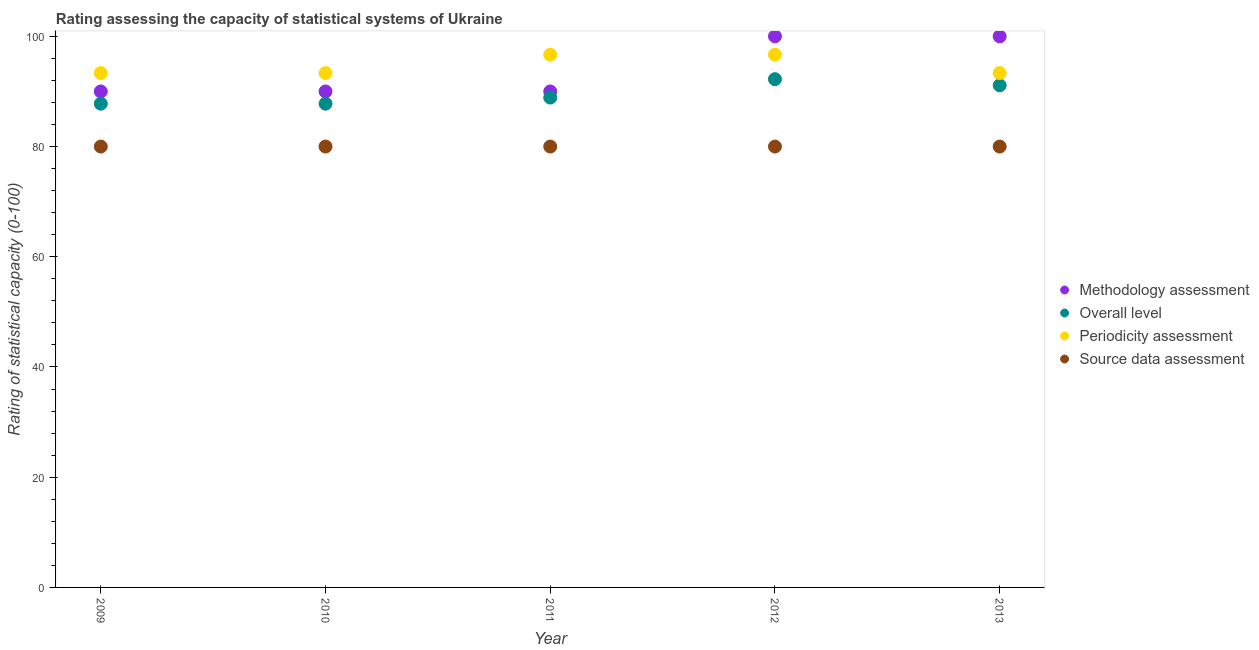How many different coloured dotlines are there?
Provide a short and direct response. 4. Is the number of dotlines equal to the number of legend labels?
Your response must be concise. Yes. What is the overall level rating in 2013?
Make the answer very short. 91.11. Across all years, what is the maximum overall level rating?
Keep it short and to the point. 92.22. Across all years, what is the minimum overall level rating?
Your answer should be compact. 87.78. In which year was the source data assessment rating minimum?
Make the answer very short. 2009. What is the total overall level rating in the graph?
Your response must be concise. 447.78. What is the difference between the source data assessment rating in 2013 and the periodicity assessment rating in 2009?
Keep it short and to the point. -13.33. What is the average periodicity assessment rating per year?
Offer a terse response. 94.67. In the year 2012, what is the difference between the methodology assessment rating and source data assessment rating?
Offer a terse response. 20. What is the ratio of the methodology assessment rating in 2009 to that in 2013?
Provide a succinct answer. 0.9. What is the difference between the highest and the second highest methodology assessment rating?
Offer a very short reply. 0. Is it the case that in every year, the sum of the methodology assessment rating and overall level rating is greater than the periodicity assessment rating?
Make the answer very short. Yes. Does the periodicity assessment rating monotonically increase over the years?
Your answer should be very brief. No. Is the overall level rating strictly greater than the source data assessment rating over the years?
Provide a succinct answer. Yes. How many dotlines are there?
Give a very brief answer. 4. How many years are there in the graph?
Keep it short and to the point. 5. What is the difference between two consecutive major ticks on the Y-axis?
Offer a very short reply. 20. Does the graph contain grids?
Give a very brief answer. No. How many legend labels are there?
Your response must be concise. 4. How are the legend labels stacked?
Provide a short and direct response. Vertical. What is the title of the graph?
Give a very brief answer. Rating assessing the capacity of statistical systems of Ukraine. What is the label or title of the X-axis?
Your response must be concise. Year. What is the label or title of the Y-axis?
Your answer should be compact. Rating of statistical capacity (0-100). What is the Rating of statistical capacity (0-100) in Overall level in 2009?
Provide a short and direct response. 87.78. What is the Rating of statistical capacity (0-100) of Periodicity assessment in 2009?
Your answer should be compact. 93.33. What is the Rating of statistical capacity (0-100) of Source data assessment in 2009?
Offer a very short reply. 80. What is the Rating of statistical capacity (0-100) of Overall level in 2010?
Your answer should be very brief. 87.78. What is the Rating of statistical capacity (0-100) of Periodicity assessment in 2010?
Make the answer very short. 93.33. What is the Rating of statistical capacity (0-100) of Overall level in 2011?
Give a very brief answer. 88.89. What is the Rating of statistical capacity (0-100) of Periodicity assessment in 2011?
Your response must be concise. 96.67. What is the Rating of statistical capacity (0-100) in Methodology assessment in 2012?
Provide a succinct answer. 100. What is the Rating of statistical capacity (0-100) in Overall level in 2012?
Ensure brevity in your answer.  92.22. What is the Rating of statistical capacity (0-100) of Periodicity assessment in 2012?
Your answer should be compact. 96.67. What is the Rating of statistical capacity (0-100) in Source data assessment in 2012?
Offer a very short reply. 80. What is the Rating of statistical capacity (0-100) of Overall level in 2013?
Provide a short and direct response. 91.11. What is the Rating of statistical capacity (0-100) in Periodicity assessment in 2013?
Give a very brief answer. 93.33. What is the Rating of statistical capacity (0-100) of Source data assessment in 2013?
Offer a very short reply. 80. Across all years, what is the maximum Rating of statistical capacity (0-100) of Methodology assessment?
Your answer should be very brief. 100. Across all years, what is the maximum Rating of statistical capacity (0-100) in Overall level?
Make the answer very short. 92.22. Across all years, what is the maximum Rating of statistical capacity (0-100) of Periodicity assessment?
Give a very brief answer. 96.67. Across all years, what is the maximum Rating of statistical capacity (0-100) of Source data assessment?
Offer a terse response. 80. Across all years, what is the minimum Rating of statistical capacity (0-100) of Overall level?
Make the answer very short. 87.78. Across all years, what is the minimum Rating of statistical capacity (0-100) in Periodicity assessment?
Your answer should be very brief. 93.33. What is the total Rating of statistical capacity (0-100) in Methodology assessment in the graph?
Your answer should be compact. 470. What is the total Rating of statistical capacity (0-100) of Overall level in the graph?
Make the answer very short. 447.78. What is the total Rating of statistical capacity (0-100) in Periodicity assessment in the graph?
Give a very brief answer. 473.33. What is the total Rating of statistical capacity (0-100) in Source data assessment in the graph?
Offer a very short reply. 400. What is the difference between the Rating of statistical capacity (0-100) in Methodology assessment in 2009 and that in 2010?
Your answer should be very brief. 0. What is the difference between the Rating of statistical capacity (0-100) of Overall level in 2009 and that in 2010?
Give a very brief answer. 0. What is the difference between the Rating of statistical capacity (0-100) in Source data assessment in 2009 and that in 2010?
Your response must be concise. 0. What is the difference between the Rating of statistical capacity (0-100) in Overall level in 2009 and that in 2011?
Keep it short and to the point. -1.11. What is the difference between the Rating of statistical capacity (0-100) of Source data assessment in 2009 and that in 2011?
Your answer should be very brief. 0. What is the difference between the Rating of statistical capacity (0-100) in Methodology assessment in 2009 and that in 2012?
Keep it short and to the point. -10. What is the difference between the Rating of statistical capacity (0-100) of Overall level in 2009 and that in 2012?
Your answer should be very brief. -4.44. What is the difference between the Rating of statistical capacity (0-100) of Periodicity assessment in 2009 and that in 2012?
Give a very brief answer. -3.33. What is the difference between the Rating of statistical capacity (0-100) in Source data assessment in 2009 and that in 2012?
Your answer should be compact. 0. What is the difference between the Rating of statistical capacity (0-100) in Methodology assessment in 2009 and that in 2013?
Keep it short and to the point. -10. What is the difference between the Rating of statistical capacity (0-100) of Source data assessment in 2009 and that in 2013?
Provide a succinct answer. 0. What is the difference between the Rating of statistical capacity (0-100) in Methodology assessment in 2010 and that in 2011?
Provide a succinct answer. 0. What is the difference between the Rating of statistical capacity (0-100) in Overall level in 2010 and that in 2011?
Offer a terse response. -1.11. What is the difference between the Rating of statistical capacity (0-100) in Overall level in 2010 and that in 2012?
Your answer should be compact. -4.44. What is the difference between the Rating of statistical capacity (0-100) of Periodicity assessment in 2010 and that in 2012?
Your answer should be compact. -3.33. What is the difference between the Rating of statistical capacity (0-100) of Source data assessment in 2010 and that in 2012?
Provide a short and direct response. 0. What is the difference between the Rating of statistical capacity (0-100) in Periodicity assessment in 2010 and that in 2013?
Offer a very short reply. -0. What is the difference between the Rating of statistical capacity (0-100) of Source data assessment in 2010 and that in 2013?
Your response must be concise. 0. What is the difference between the Rating of statistical capacity (0-100) in Methodology assessment in 2011 and that in 2012?
Provide a short and direct response. -10. What is the difference between the Rating of statistical capacity (0-100) of Overall level in 2011 and that in 2012?
Ensure brevity in your answer.  -3.33. What is the difference between the Rating of statistical capacity (0-100) of Source data assessment in 2011 and that in 2012?
Make the answer very short. 0. What is the difference between the Rating of statistical capacity (0-100) in Overall level in 2011 and that in 2013?
Your answer should be very brief. -2.22. What is the difference between the Rating of statistical capacity (0-100) of Periodicity assessment in 2011 and that in 2013?
Give a very brief answer. 3.33. What is the difference between the Rating of statistical capacity (0-100) of Methodology assessment in 2012 and that in 2013?
Provide a short and direct response. 0. What is the difference between the Rating of statistical capacity (0-100) in Periodicity assessment in 2012 and that in 2013?
Provide a succinct answer. 3.33. What is the difference between the Rating of statistical capacity (0-100) of Methodology assessment in 2009 and the Rating of statistical capacity (0-100) of Overall level in 2010?
Keep it short and to the point. 2.22. What is the difference between the Rating of statistical capacity (0-100) in Overall level in 2009 and the Rating of statistical capacity (0-100) in Periodicity assessment in 2010?
Your answer should be compact. -5.56. What is the difference between the Rating of statistical capacity (0-100) of Overall level in 2009 and the Rating of statistical capacity (0-100) of Source data assessment in 2010?
Offer a terse response. 7.78. What is the difference between the Rating of statistical capacity (0-100) in Periodicity assessment in 2009 and the Rating of statistical capacity (0-100) in Source data assessment in 2010?
Offer a terse response. 13.33. What is the difference between the Rating of statistical capacity (0-100) in Methodology assessment in 2009 and the Rating of statistical capacity (0-100) in Overall level in 2011?
Provide a short and direct response. 1.11. What is the difference between the Rating of statistical capacity (0-100) of Methodology assessment in 2009 and the Rating of statistical capacity (0-100) of Periodicity assessment in 2011?
Keep it short and to the point. -6.67. What is the difference between the Rating of statistical capacity (0-100) of Overall level in 2009 and the Rating of statistical capacity (0-100) of Periodicity assessment in 2011?
Ensure brevity in your answer.  -8.89. What is the difference between the Rating of statistical capacity (0-100) of Overall level in 2009 and the Rating of statistical capacity (0-100) of Source data assessment in 2011?
Your answer should be compact. 7.78. What is the difference between the Rating of statistical capacity (0-100) of Periodicity assessment in 2009 and the Rating of statistical capacity (0-100) of Source data assessment in 2011?
Keep it short and to the point. 13.33. What is the difference between the Rating of statistical capacity (0-100) in Methodology assessment in 2009 and the Rating of statistical capacity (0-100) in Overall level in 2012?
Make the answer very short. -2.22. What is the difference between the Rating of statistical capacity (0-100) of Methodology assessment in 2009 and the Rating of statistical capacity (0-100) of Periodicity assessment in 2012?
Offer a terse response. -6.67. What is the difference between the Rating of statistical capacity (0-100) in Methodology assessment in 2009 and the Rating of statistical capacity (0-100) in Source data assessment in 2012?
Offer a terse response. 10. What is the difference between the Rating of statistical capacity (0-100) in Overall level in 2009 and the Rating of statistical capacity (0-100) in Periodicity assessment in 2012?
Make the answer very short. -8.89. What is the difference between the Rating of statistical capacity (0-100) in Overall level in 2009 and the Rating of statistical capacity (0-100) in Source data assessment in 2012?
Offer a terse response. 7.78. What is the difference between the Rating of statistical capacity (0-100) of Periodicity assessment in 2009 and the Rating of statistical capacity (0-100) of Source data assessment in 2012?
Provide a short and direct response. 13.33. What is the difference between the Rating of statistical capacity (0-100) in Methodology assessment in 2009 and the Rating of statistical capacity (0-100) in Overall level in 2013?
Keep it short and to the point. -1.11. What is the difference between the Rating of statistical capacity (0-100) of Overall level in 2009 and the Rating of statistical capacity (0-100) of Periodicity assessment in 2013?
Make the answer very short. -5.56. What is the difference between the Rating of statistical capacity (0-100) in Overall level in 2009 and the Rating of statistical capacity (0-100) in Source data assessment in 2013?
Provide a short and direct response. 7.78. What is the difference between the Rating of statistical capacity (0-100) in Periodicity assessment in 2009 and the Rating of statistical capacity (0-100) in Source data assessment in 2013?
Your answer should be very brief. 13.33. What is the difference between the Rating of statistical capacity (0-100) of Methodology assessment in 2010 and the Rating of statistical capacity (0-100) of Periodicity assessment in 2011?
Give a very brief answer. -6.67. What is the difference between the Rating of statistical capacity (0-100) of Overall level in 2010 and the Rating of statistical capacity (0-100) of Periodicity assessment in 2011?
Provide a short and direct response. -8.89. What is the difference between the Rating of statistical capacity (0-100) in Overall level in 2010 and the Rating of statistical capacity (0-100) in Source data assessment in 2011?
Your response must be concise. 7.78. What is the difference between the Rating of statistical capacity (0-100) of Periodicity assessment in 2010 and the Rating of statistical capacity (0-100) of Source data assessment in 2011?
Make the answer very short. 13.33. What is the difference between the Rating of statistical capacity (0-100) of Methodology assessment in 2010 and the Rating of statistical capacity (0-100) of Overall level in 2012?
Offer a terse response. -2.22. What is the difference between the Rating of statistical capacity (0-100) in Methodology assessment in 2010 and the Rating of statistical capacity (0-100) in Periodicity assessment in 2012?
Make the answer very short. -6.67. What is the difference between the Rating of statistical capacity (0-100) in Overall level in 2010 and the Rating of statistical capacity (0-100) in Periodicity assessment in 2012?
Keep it short and to the point. -8.89. What is the difference between the Rating of statistical capacity (0-100) of Overall level in 2010 and the Rating of statistical capacity (0-100) of Source data assessment in 2012?
Provide a short and direct response. 7.78. What is the difference between the Rating of statistical capacity (0-100) in Periodicity assessment in 2010 and the Rating of statistical capacity (0-100) in Source data assessment in 2012?
Offer a very short reply. 13.33. What is the difference between the Rating of statistical capacity (0-100) in Methodology assessment in 2010 and the Rating of statistical capacity (0-100) in Overall level in 2013?
Give a very brief answer. -1.11. What is the difference between the Rating of statistical capacity (0-100) in Overall level in 2010 and the Rating of statistical capacity (0-100) in Periodicity assessment in 2013?
Give a very brief answer. -5.56. What is the difference between the Rating of statistical capacity (0-100) of Overall level in 2010 and the Rating of statistical capacity (0-100) of Source data assessment in 2013?
Keep it short and to the point. 7.78. What is the difference between the Rating of statistical capacity (0-100) of Periodicity assessment in 2010 and the Rating of statistical capacity (0-100) of Source data assessment in 2013?
Provide a short and direct response. 13.33. What is the difference between the Rating of statistical capacity (0-100) in Methodology assessment in 2011 and the Rating of statistical capacity (0-100) in Overall level in 2012?
Your answer should be compact. -2.22. What is the difference between the Rating of statistical capacity (0-100) of Methodology assessment in 2011 and the Rating of statistical capacity (0-100) of Periodicity assessment in 2012?
Provide a succinct answer. -6.67. What is the difference between the Rating of statistical capacity (0-100) of Methodology assessment in 2011 and the Rating of statistical capacity (0-100) of Source data assessment in 2012?
Your answer should be compact. 10. What is the difference between the Rating of statistical capacity (0-100) in Overall level in 2011 and the Rating of statistical capacity (0-100) in Periodicity assessment in 2012?
Make the answer very short. -7.78. What is the difference between the Rating of statistical capacity (0-100) of Overall level in 2011 and the Rating of statistical capacity (0-100) of Source data assessment in 2012?
Make the answer very short. 8.89. What is the difference between the Rating of statistical capacity (0-100) in Periodicity assessment in 2011 and the Rating of statistical capacity (0-100) in Source data assessment in 2012?
Make the answer very short. 16.67. What is the difference between the Rating of statistical capacity (0-100) of Methodology assessment in 2011 and the Rating of statistical capacity (0-100) of Overall level in 2013?
Your answer should be compact. -1.11. What is the difference between the Rating of statistical capacity (0-100) of Methodology assessment in 2011 and the Rating of statistical capacity (0-100) of Periodicity assessment in 2013?
Your answer should be very brief. -3.33. What is the difference between the Rating of statistical capacity (0-100) in Overall level in 2011 and the Rating of statistical capacity (0-100) in Periodicity assessment in 2013?
Your answer should be very brief. -4.44. What is the difference between the Rating of statistical capacity (0-100) of Overall level in 2011 and the Rating of statistical capacity (0-100) of Source data assessment in 2013?
Offer a very short reply. 8.89. What is the difference between the Rating of statistical capacity (0-100) in Periodicity assessment in 2011 and the Rating of statistical capacity (0-100) in Source data assessment in 2013?
Offer a terse response. 16.67. What is the difference between the Rating of statistical capacity (0-100) in Methodology assessment in 2012 and the Rating of statistical capacity (0-100) in Overall level in 2013?
Your answer should be very brief. 8.89. What is the difference between the Rating of statistical capacity (0-100) of Overall level in 2012 and the Rating of statistical capacity (0-100) of Periodicity assessment in 2013?
Offer a terse response. -1.11. What is the difference between the Rating of statistical capacity (0-100) in Overall level in 2012 and the Rating of statistical capacity (0-100) in Source data assessment in 2013?
Provide a short and direct response. 12.22. What is the difference between the Rating of statistical capacity (0-100) of Periodicity assessment in 2012 and the Rating of statistical capacity (0-100) of Source data assessment in 2013?
Keep it short and to the point. 16.67. What is the average Rating of statistical capacity (0-100) of Methodology assessment per year?
Provide a short and direct response. 94. What is the average Rating of statistical capacity (0-100) in Overall level per year?
Give a very brief answer. 89.56. What is the average Rating of statistical capacity (0-100) of Periodicity assessment per year?
Provide a succinct answer. 94.67. What is the average Rating of statistical capacity (0-100) of Source data assessment per year?
Your answer should be compact. 80. In the year 2009, what is the difference between the Rating of statistical capacity (0-100) of Methodology assessment and Rating of statistical capacity (0-100) of Overall level?
Make the answer very short. 2.22. In the year 2009, what is the difference between the Rating of statistical capacity (0-100) of Overall level and Rating of statistical capacity (0-100) of Periodicity assessment?
Give a very brief answer. -5.56. In the year 2009, what is the difference between the Rating of statistical capacity (0-100) in Overall level and Rating of statistical capacity (0-100) in Source data assessment?
Ensure brevity in your answer.  7.78. In the year 2009, what is the difference between the Rating of statistical capacity (0-100) of Periodicity assessment and Rating of statistical capacity (0-100) of Source data assessment?
Make the answer very short. 13.33. In the year 2010, what is the difference between the Rating of statistical capacity (0-100) of Methodology assessment and Rating of statistical capacity (0-100) of Overall level?
Make the answer very short. 2.22. In the year 2010, what is the difference between the Rating of statistical capacity (0-100) in Methodology assessment and Rating of statistical capacity (0-100) in Periodicity assessment?
Your response must be concise. -3.33. In the year 2010, what is the difference between the Rating of statistical capacity (0-100) of Methodology assessment and Rating of statistical capacity (0-100) of Source data assessment?
Your answer should be very brief. 10. In the year 2010, what is the difference between the Rating of statistical capacity (0-100) in Overall level and Rating of statistical capacity (0-100) in Periodicity assessment?
Offer a terse response. -5.56. In the year 2010, what is the difference between the Rating of statistical capacity (0-100) of Overall level and Rating of statistical capacity (0-100) of Source data assessment?
Keep it short and to the point. 7.78. In the year 2010, what is the difference between the Rating of statistical capacity (0-100) in Periodicity assessment and Rating of statistical capacity (0-100) in Source data assessment?
Provide a succinct answer. 13.33. In the year 2011, what is the difference between the Rating of statistical capacity (0-100) of Methodology assessment and Rating of statistical capacity (0-100) of Overall level?
Ensure brevity in your answer.  1.11. In the year 2011, what is the difference between the Rating of statistical capacity (0-100) of Methodology assessment and Rating of statistical capacity (0-100) of Periodicity assessment?
Your answer should be very brief. -6.67. In the year 2011, what is the difference between the Rating of statistical capacity (0-100) of Methodology assessment and Rating of statistical capacity (0-100) of Source data assessment?
Keep it short and to the point. 10. In the year 2011, what is the difference between the Rating of statistical capacity (0-100) in Overall level and Rating of statistical capacity (0-100) in Periodicity assessment?
Give a very brief answer. -7.78. In the year 2011, what is the difference between the Rating of statistical capacity (0-100) in Overall level and Rating of statistical capacity (0-100) in Source data assessment?
Keep it short and to the point. 8.89. In the year 2011, what is the difference between the Rating of statistical capacity (0-100) in Periodicity assessment and Rating of statistical capacity (0-100) in Source data assessment?
Provide a short and direct response. 16.67. In the year 2012, what is the difference between the Rating of statistical capacity (0-100) of Methodology assessment and Rating of statistical capacity (0-100) of Overall level?
Your response must be concise. 7.78. In the year 2012, what is the difference between the Rating of statistical capacity (0-100) of Methodology assessment and Rating of statistical capacity (0-100) of Periodicity assessment?
Provide a short and direct response. 3.33. In the year 2012, what is the difference between the Rating of statistical capacity (0-100) of Overall level and Rating of statistical capacity (0-100) of Periodicity assessment?
Ensure brevity in your answer.  -4.44. In the year 2012, what is the difference between the Rating of statistical capacity (0-100) in Overall level and Rating of statistical capacity (0-100) in Source data assessment?
Ensure brevity in your answer.  12.22. In the year 2012, what is the difference between the Rating of statistical capacity (0-100) in Periodicity assessment and Rating of statistical capacity (0-100) in Source data assessment?
Your answer should be compact. 16.67. In the year 2013, what is the difference between the Rating of statistical capacity (0-100) of Methodology assessment and Rating of statistical capacity (0-100) of Overall level?
Your answer should be compact. 8.89. In the year 2013, what is the difference between the Rating of statistical capacity (0-100) in Overall level and Rating of statistical capacity (0-100) in Periodicity assessment?
Make the answer very short. -2.22. In the year 2013, what is the difference between the Rating of statistical capacity (0-100) of Overall level and Rating of statistical capacity (0-100) of Source data assessment?
Give a very brief answer. 11.11. In the year 2013, what is the difference between the Rating of statistical capacity (0-100) in Periodicity assessment and Rating of statistical capacity (0-100) in Source data assessment?
Give a very brief answer. 13.33. What is the ratio of the Rating of statistical capacity (0-100) in Overall level in 2009 to that in 2010?
Provide a succinct answer. 1. What is the ratio of the Rating of statistical capacity (0-100) in Periodicity assessment in 2009 to that in 2010?
Make the answer very short. 1. What is the ratio of the Rating of statistical capacity (0-100) in Overall level in 2009 to that in 2011?
Offer a very short reply. 0.99. What is the ratio of the Rating of statistical capacity (0-100) in Periodicity assessment in 2009 to that in 2011?
Make the answer very short. 0.97. What is the ratio of the Rating of statistical capacity (0-100) of Source data assessment in 2009 to that in 2011?
Your response must be concise. 1. What is the ratio of the Rating of statistical capacity (0-100) of Overall level in 2009 to that in 2012?
Your answer should be very brief. 0.95. What is the ratio of the Rating of statistical capacity (0-100) in Periodicity assessment in 2009 to that in 2012?
Keep it short and to the point. 0.97. What is the ratio of the Rating of statistical capacity (0-100) of Source data assessment in 2009 to that in 2012?
Offer a very short reply. 1. What is the ratio of the Rating of statistical capacity (0-100) of Overall level in 2009 to that in 2013?
Provide a succinct answer. 0.96. What is the ratio of the Rating of statistical capacity (0-100) of Overall level in 2010 to that in 2011?
Keep it short and to the point. 0.99. What is the ratio of the Rating of statistical capacity (0-100) in Periodicity assessment in 2010 to that in 2011?
Provide a short and direct response. 0.97. What is the ratio of the Rating of statistical capacity (0-100) in Source data assessment in 2010 to that in 2011?
Keep it short and to the point. 1. What is the ratio of the Rating of statistical capacity (0-100) of Methodology assessment in 2010 to that in 2012?
Ensure brevity in your answer.  0.9. What is the ratio of the Rating of statistical capacity (0-100) of Overall level in 2010 to that in 2012?
Keep it short and to the point. 0.95. What is the ratio of the Rating of statistical capacity (0-100) in Periodicity assessment in 2010 to that in 2012?
Offer a very short reply. 0.97. What is the ratio of the Rating of statistical capacity (0-100) in Overall level in 2010 to that in 2013?
Your answer should be very brief. 0.96. What is the ratio of the Rating of statistical capacity (0-100) in Source data assessment in 2010 to that in 2013?
Your answer should be compact. 1. What is the ratio of the Rating of statistical capacity (0-100) in Overall level in 2011 to that in 2012?
Keep it short and to the point. 0.96. What is the ratio of the Rating of statistical capacity (0-100) of Source data assessment in 2011 to that in 2012?
Your answer should be compact. 1. What is the ratio of the Rating of statistical capacity (0-100) in Methodology assessment in 2011 to that in 2013?
Your response must be concise. 0.9. What is the ratio of the Rating of statistical capacity (0-100) of Overall level in 2011 to that in 2013?
Your answer should be very brief. 0.98. What is the ratio of the Rating of statistical capacity (0-100) of Periodicity assessment in 2011 to that in 2013?
Ensure brevity in your answer.  1.04. What is the ratio of the Rating of statistical capacity (0-100) of Overall level in 2012 to that in 2013?
Your answer should be very brief. 1.01. What is the ratio of the Rating of statistical capacity (0-100) of Periodicity assessment in 2012 to that in 2013?
Make the answer very short. 1.04. What is the difference between the highest and the second highest Rating of statistical capacity (0-100) of Overall level?
Provide a succinct answer. 1.11. What is the difference between the highest and the second highest Rating of statistical capacity (0-100) in Source data assessment?
Offer a very short reply. 0. What is the difference between the highest and the lowest Rating of statistical capacity (0-100) in Methodology assessment?
Give a very brief answer. 10. What is the difference between the highest and the lowest Rating of statistical capacity (0-100) in Overall level?
Make the answer very short. 4.44. What is the difference between the highest and the lowest Rating of statistical capacity (0-100) in Periodicity assessment?
Your answer should be very brief. 3.33. 